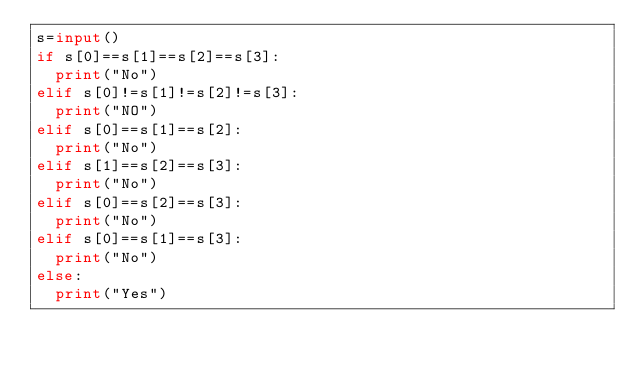<code> <loc_0><loc_0><loc_500><loc_500><_Python_>s=input() 
if s[0]==s[1]==s[2]==s[3]:
  print("No")
elif s[0]!=s[1]!=s[2]!=s[3]:
  print("NO")
elif s[0]==s[1]==s[2]:
  print("No")
elif s[1]==s[2]==s[3]:
  print("No")
elif s[0]==s[2]==s[3]:
  print("No")
elif s[0]==s[1]==s[3]:
  print("No")
else:
  print("Yes")</code> 